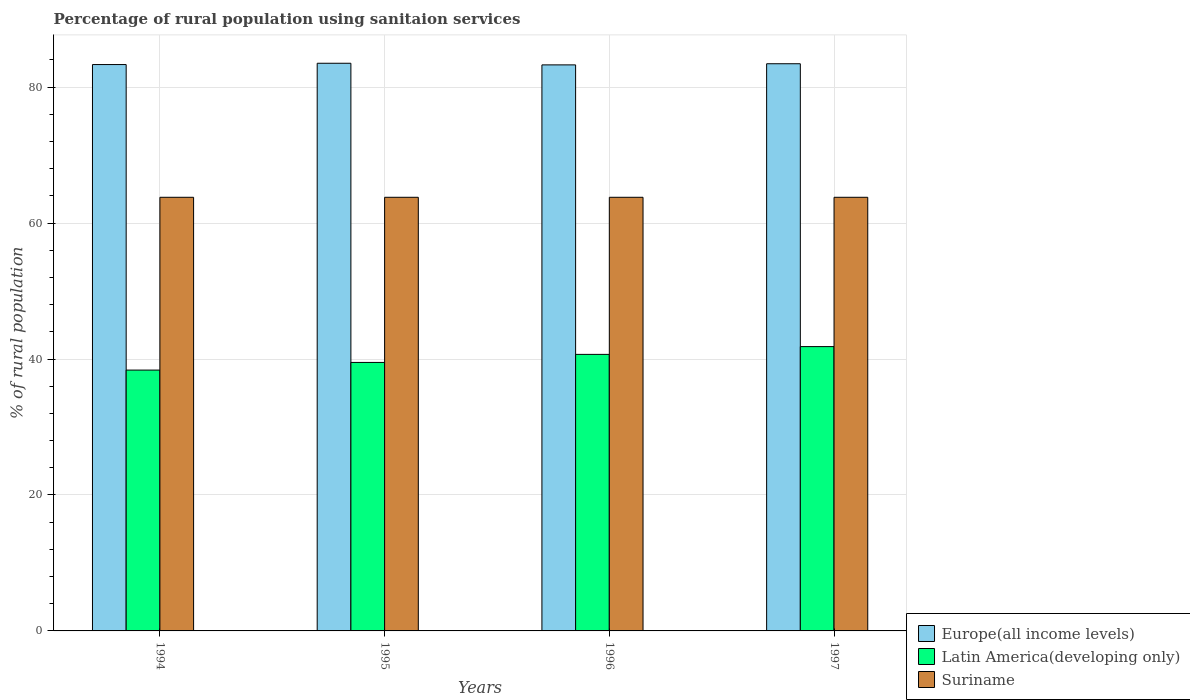What is the label of the 3rd group of bars from the left?
Offer a terse response. 1996. What is the percentage of rural population using sanitaion services in Suriname in 1995?
Offer a terse response. 63.8. Across all years, what is the maximum percentage of rural population using sanitaion services in Europe(all income levels)?
Provide a succinct answer. 83.52. Across all years, what is the minimum percentage of rural population using sanitaion services in Europe(all income levels)?
Give a very brief answer. 83.28. What is the total percentage of rural population using sanitaion services in Suriname in the graph?
Keep it short and to the point. 255.2. What is the difference between the percentage of rural population using sanitaion services in Latin America(developing only) in 1994 and that in 1996?
Your answer should be compact. -2.31. What is the difference between the percentage of rural population using sanitaion services in Latin America(developing only) in 1997 and the percentage of rural population using sanitaion services in Europe(all income levels) in 1996?
Provide a succinct answer. -41.45. What is the average percentage of rural population using sanitaion services in Latin America(developing only) per year?
Ensure brevity in your answer.  40.1. In the year 1997, what is the difference between the percentage of rural population using sanitaion services in Latin America(developing only) and percentage of rural population using sanitaion services in Suriname?
Provide a short and direct response. -21.97. What is the ratio of the percentage of rural population using sanitaion services in Suriname in 1995 to that in 1997?
Make the answer very short. 1. Is the percentage of rural population using sanitaion services in Latin America(developing only) in 1995 less than that in 1997?
Offer a terse response. Yes. Is the difference between the percentage of rural population using sanitaion services in Latin America(developing only) in 1994 and 1995 greater than the difference between the percentage of rural population using sanitaion services in Suriname in 1994 and 1995?
Ensure brevity in your answer.  No. What is the difference between the highest and the second highest percentage of rural population using sanitaion services in Suriname?
Offer a very short reply. 0. What is the difference between the highest and the lowest percentage of rural population using sanitaion services in Latin America(developing only)?
Your answer should be compact. 3.46. What does the 1st bar from the left in 1997 represents?
Give a very brief answer. Europe(all income levels). What does the 3rd bar from the right in 1995 represents?
Your answer should be compact. Europe(all income levels). Is it the case that in every year, the sum of the percentage of rural population using sanitaion services in Latin America(developing only) and percentage of rural population using sanitaion services in Europe(all income levels) is greater than the percentage of rural population using sanitaion services in Suriname?
Your answer should be compact. Yes. How many bars are there?
Your answer should be very brief. 12. Are all the bars in the graph horizontal?
Your answer should be very brief. No. What is the difference between two consecutive major ticks on the Y-axis?
Your answer should be compact. 20. Does the graph contain grids?
Give a very brief answer. Yes. How many legend labels are there?
Provide a short and direct response. 3. How are the legend labels stacked?
Ensure brevity in your answer.  Vertical. What is the title of the graph?
Provide a succinct answer. Percentage of rural population using sanitaion services. What is the label or title of the X-axis?
Provide a short and direct response. Years. What is the label or title of the Y-axis?
Your answer should be very brief. % of rural population. What is the % of rural population of Europe(all income levels) in 1994?
Provide a short and direct response. 83.33. What is the % of rural population of Latin America(developing only) in 1994?
Offer a terse response. 38.37. What is the % of rural population in Suriname in 1994?
Your response must be concise. 63.8. What is the % of rural population in Europe(all income levels) in 1995?
Ensure brevity in your answer.  83.52. What is the % of rural population in Latin America(developing only) in 1995?
Ensure brevity in your answer.  39.5. What is the % of rural population of Suriname in 1995?
Your answer should be very brief. 63.8. What is the % of rural population in Europe(all income levels) in 1996?
Give a very brief answer. 83.28. What is the % of rural population of Latin America(developing only) in 1996?
Provide a short and direct response. 40.69. What is the % of rural population of Suriname in 1996?
Give a very brief answer. 63.8. What is the % of rural population in Europe(all income levels) in 1997?
Ensure brevity in your answer.  83.45. What is the % of rural population in Latin America(developing only) in 1997?
Provide a short and direct response. 41.83. What is the % of rural population of Suriname in 1997?
Your response must be concise. 63.8. Across all years, what is the maximum % of rural population of Europe(all income levels)?
Provide a short and direct response. 83.52. Across all years, what is the maximum % of rural population in Latin America(developing only)?
Offer a terse response. 41.83. Across all years, what is the maximum % of rural population of Suriname?
Your answer should be compact. 63.8. Across all years, what is the minimum % of rural population of Europe(all income levels)?
Offer a terse response. 83.28. Across all years, what is the minimum % of rural population of Latin America(developing only)?
Your answer should be very brief. 38.37. Across all years, what is the minimum % of rural population of Suriname?
Make the answer very short. 63.8. What is the total % of rural population in Europe(all income levels) in the graph?
Your response must be concise. 333.57. What is the total % of rural population of Latin America(developing only) in the graph?
Offer a terse response. 160.4. What is the total % of rural population of Suriname in the graph?
Offer a very short reply. 255.2. What is the difference between the % of rural population of Europe(all income levels) in 1994 and that in 1995?
Offer a terse response. -0.19. What is the difference between the % of rural population of Latin America(developing only) in 1994 and that in 1995?
Make the answer very short. -1.13. What is the difference between the % of rural population in Suriname in 1994 and that in 1995?
Offer a very short reply. 0. What is the difference between the % of rural population of Europe(all income levels) in 1994 and that in 1996?
Your response must be concise. 0.05. What is the difference between the % of rural population of Latin America(developing only) in 1994 and that in 1996?
Provide a succinct answer. -2.31. What is the difference between the % of rural population of Europe(all income levels) in 1994 and that in 1997?
Provide a succinct answer. -0.12. What is the difference between the % of rural population of Latin America(developing only) in 1994 and that in 1997?
Your response must be concise. -3.46. What is the difference between the % of rural population of Suriname in 1994 and that in 1997?
Provide a short and direct response. 0. What is the difference between the % of rural population in Europe(all income levels) in 1995 and that in 1996?
Your answer should be very brief. 0.24. What is the difference between the % of rural population of Latin America(developing only) in 1995 and that in 1996?
Provide a short and direct response. -1.19. What is the difference between the % of rural population of Europe(all income levels) in 1995 and that in 1997?
Keep it short and to the point. 0.07. What is the difference between the % of rural population in Latin America(developing only) in 1995 and that in 1997?
Make the answer very short. -2.33. What is the difference between the % of rural population in Europe(all income levels) in 1996 and that in 1997?
Provide a short and direct response. -0.17. What is the difference between the % of rural population of Latin America(developing only) in 1996 and that in 1997?
Offer a terse response. -1.14. What is the difference between the % of rural population in Suriname in 1996 and that in 1997?
Make the answer very short. 0. What is the difference between the % of rural population in Europe(all income levels) in 1994 and the % of rural population in Latin America(developing only) in 1995?
Your answer should be compact. 43.83. What is the difference between the % of rural population of Europe(all income levels) in 1994 and the % of rural population of Suriname in 1995?
Give a very brief answer. 19.53. What is the difference between the % of rural population in Latin America(developing only) in 1994 and the % of rural population in Suriname in 1995?
Offer a terse response. -25.43. What is the difference between the % of rural population of Europe(all income levels) in 1994 and the % of rural population of Latin America(developing only) in 1996?
Offer a very short reply. 42.64. What is the difference between the % of rural population of Europe(all income levels) in 1994 and the % of rural population of Suriname in 1996?
Offer a very short reply. 19.53. What is the difference between the % of rural population of Latin America(developing only) in 1994 and the % of rural population of Suriname in 1996?
Provide a short and direct response. -25.43. What is the difference between the % of rural population of Europe(all income levels) in 1994 and the % of rural population of Latin America(developing only) in 1997?
Make the answer very short. 41.5. What is the difference between the % of rural population of Europe(all income levels) in 1994 and the % of rural population of Suriname in 1997?
Ensure brevity in your answer.  19.53. What is the difference between the % of rural population in Latin America(developing only) in 1994 and the % of rural population in Suriname in 1997?
Offer a very short reply. -25.43. What is the difference between the % of rural population of Europe(all income levels) in 1995 and the % of rural population of Latin America(developing only) in 1996?
Give a very brief answer. 42.83. What is the difference between the % of rural population in Europe(all income levels) in 1995 and the % of rural population in Suriname in 1996?
Your answer should be compact. 19.72. What is the difference between the % of rural population in Latin America(developing only) in 1995 and the % of rural population in Suriname in 1996?
Provide a short and direct response. -24.3. What is the difference between the % of rural population in Europe(all income levels) in 1995 and the % of rural population in Latin America(developing only) in 1997?
Provide a short and direct response. 41.69. What is the difference between the % of rural population in Europe(all income levels) in 1995 and the % of rural population in Suriname in 1997?
Offer a very short reply. 19.72. What is the difference between the % of rural population of Latin America(developing only) in 1995 and the % of rural population of Suriname in 1997?
Provide a succinct answer. -24.3. What is the difference between the % of rural population of Europe(all income levels) in 1996 and the % of rural population of Latin America(developing only) in 1997?
Your response must be concise. 41.45. What is the difference between the % of rural population of Europe(all income levels) in 1996 and the % of rural population of Suriname in 1997?
Offer a very short reply. 19.48. What is the difference between the % of rural population in Latin America(developing only) in 1996 and the % of rural population in Suriname in 1997?
Your answer should be compact. -23.11. What is the average % of rural population in Europe(all income levels) per year?
Ensure brevity in your answer.  83.39. What is the average % of rural population of Latin America(developing only) per year?
Provide a succinct answer. 40.1. What is the average % of rural population of Suriname per year?
Provide a succinct answer. 63.8. In the year 1994, what is the difference between the % of rural population of Europe(all income levels) and % of rural population of Latin America(developing only)?
Ensure brevity in your answer.  44.95. In the year 1994, what is the difference between the % of rural population of Europe(all income levels) and % of rural population of Suriname?
Offer a very short reply. 19.53. In the year 1994, what is the difference between the % of rural population in Latin America(developing only) and % of rural population in Suriname?
Give a very brief answer. -25.43. In the year 1995, what is the difference between the % of rural population in Europe(all income levels) and % of rural population in Latin America(developing only)?
Your answer should be compact. 44.02. In the year 1995, what is the difference between the % of rural population in Europe(all income levels) and % of rural population in Suriname?
Offer a terse response. 19.72. In the year 1995, what is the difference between the % of rural population in Latin America(developing only) and % of rural population in Suriname?
Make the answer very short. -24.3. In the year 1996, what is the difference between the % of rural population in Europe(all income levels) and % of rural population in Latin America(developing only)?
Give a very brief answer. 42.59. In the year 1996, what is the difference between the % of rural population of Europe(all income levels) and % of rural population of Suriname?
Offer a terse response. 19.48. In the year 1996, what is the difference between the % of rural population of Latin America(developing only) and % of rural population of Suriname?
Offer a terse response. -23.11. In the year 1997, what is the difference between the % of rural population in Europe(all income levels) and % of rural population in Latin America(developing only)?
Make the answer very short. 41.62. In the year 1997, what is the difference between the % of rural population of Europe(all income levels) and % of rural population of Suriname?
Make the answer very short. 19.65. In the year 1997, what is the difference between the % of rural population in Latin America(developing only) and % of rural population in Suriname?
Your answer should be compact. -21.97. What is the ratio of the % of rural population in Latin America(developing only) in 1994 to that in 1995?
Make the answer very short. 0.97. What is the ratio of the % of rural population in Europe(all income levels) in 1994 to that in 1996?
Ensure brevity in your answer.  1. What is the ratio of the % of rural population of Latin America(developing only) in 1994 to that in 1996?
Offer a terse response. 0.94. What is the ratio of the % of rural population in Latin America(developing only) in 1994 to that in 1997?
Provide a short and direct response. 0.92. What is the ratio of the % of rural population of Europe(all income levels) in 1995 to that in 1996?
Offer a terse response. 1. What is the ratio of the % of rural population in Latin America(developing only) in 1995 to that in 1996?
Ensure brevity in your answer.  0.97. What is the ratio of the % of rural population of Suriname in 1995 to that in 1996?
Make the answer very short. 1. What is the ratio of the % of rural population of Europe(all income levels) in 1995 to that in 1997?
Provide a succinct answer. 1. What is the ratio of the % of rural population in Latin America(developing only) in 1995 to that in 1997?
Give a very brief answer. 0.94. What is the ratio of the % of rural population in Latin America(developing only) in 1996 to that in 1997?
Offer a terse response. 0.97. What is the ratio of the % of rural population of Suriname in 1996 to that in 1997?
Make the answer very short. 1. What is the difference between the highest and the second highest % of rural population of Europe(all income levels)?
Your answer should be very brief. 0.07. What is the difference between the highest and the second highest % of rural population of Latin America(developing only)?
Your answer should be compact. 1.14. What is the difference between the highest and the lowest % of rural population of Europe(all income levels)?
Make the answer very short. 0.24. What is the difference between the highest and the lowest % of rural population of Latin America(developing only)?
Offer a terse response. 3.46. 